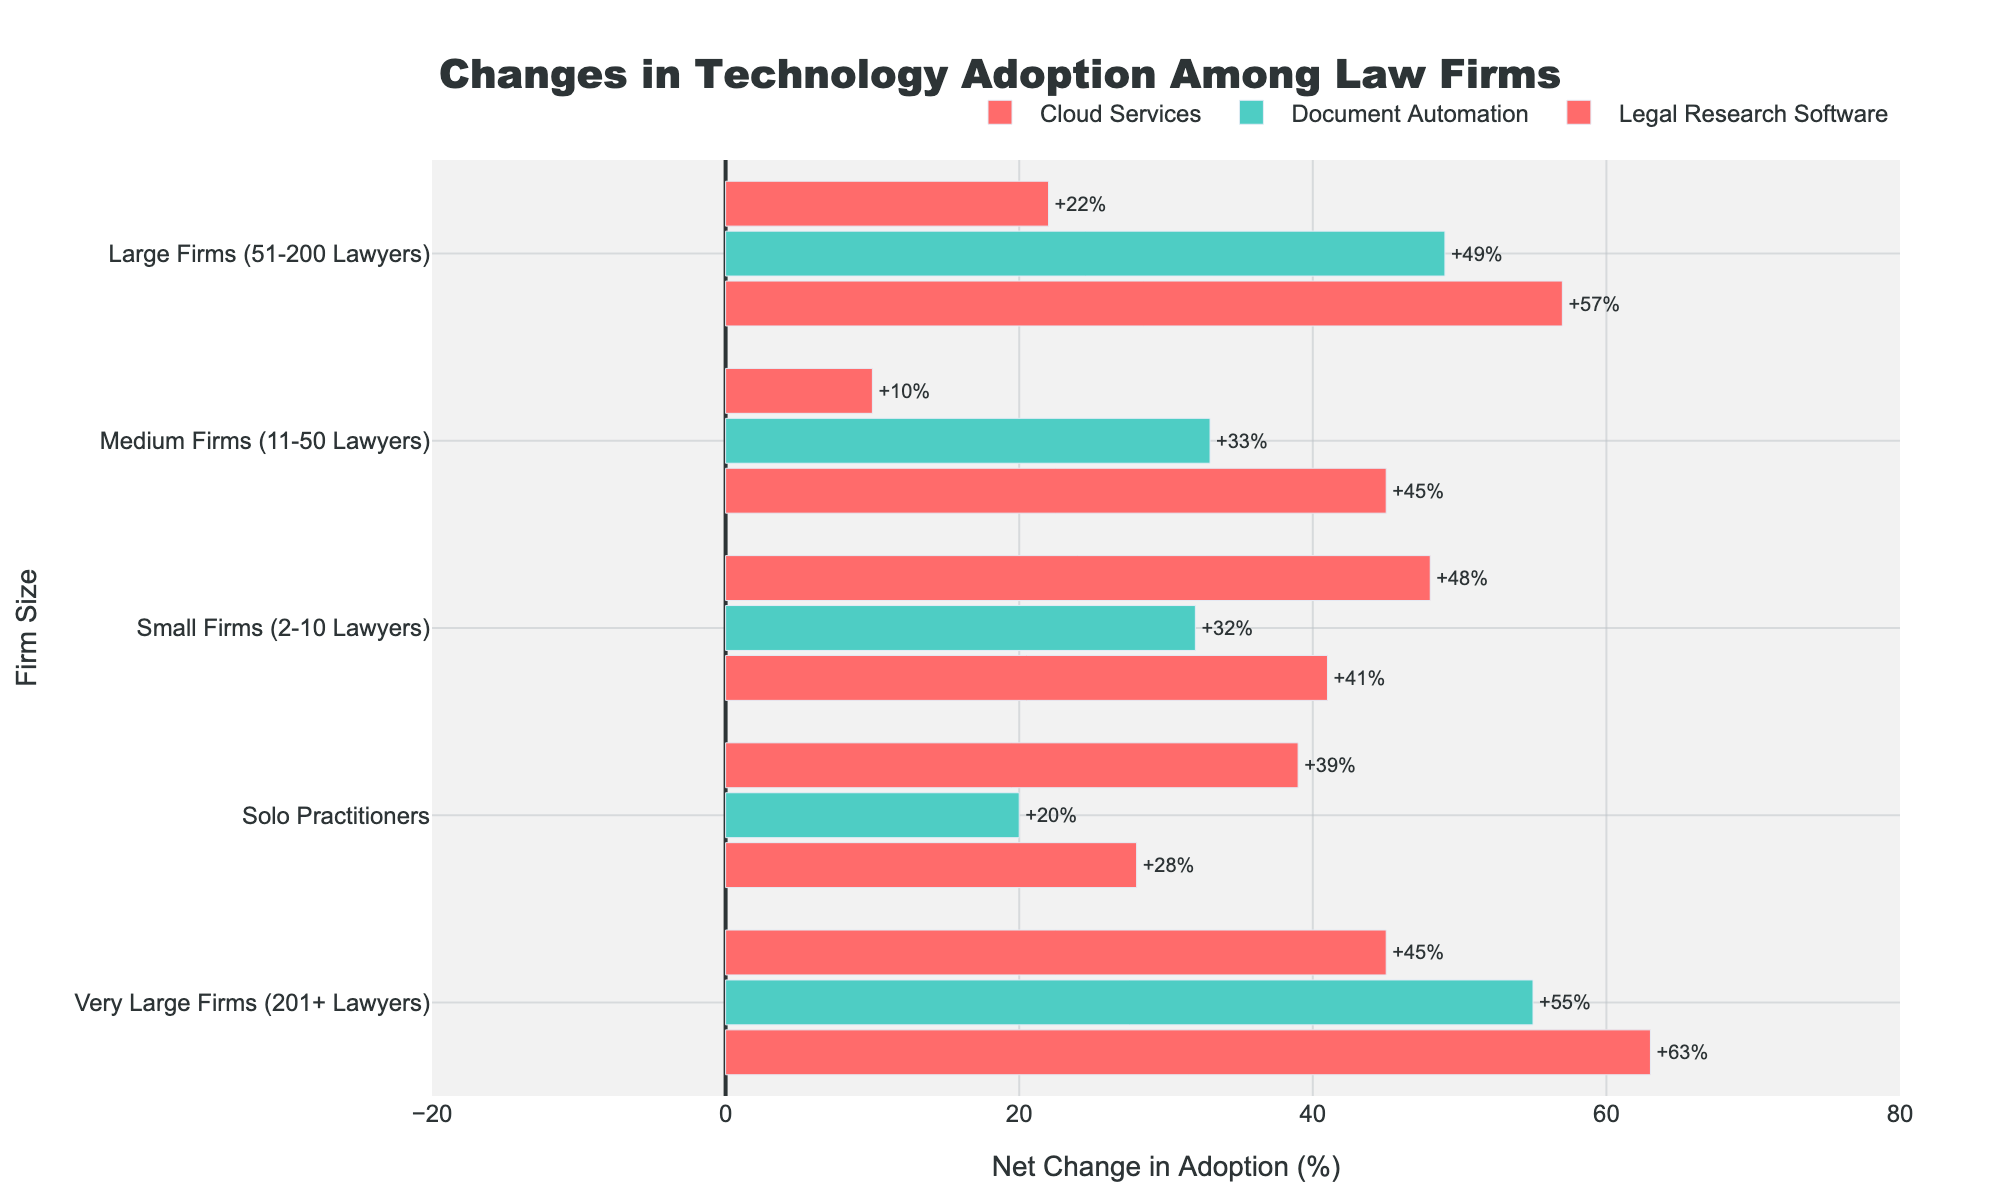What technology category experienced the highest net change in adoption for Very Large Firms (201+ Lawyers)? By comparing the net change values for each technology category within the Very Large Firms (201+ Lawyers) group, we find that Cloud Services has the highest net change.
Answer: Cloud Services Which firm size category has the smallest net increase in adoption for Legal Research Software? Looking at Legal Research Software for each firm size, we find that Medium Firms (11-50 Lawyers) have the smallest net increase at +10%.
Answer: Medium Firms (11-50 Lawyers) What is the net change in adoption for Cloud Services among Small Firms (2-10 Lawyers) and Large Firms (51-200 Lawyers), and which is higher? To answer this, we look at the Cloud Services net change for Small Firms (2-10 Lawyers) which is +41%, and for Large Firms (51-200 Lawyers) which is +57%. Thus, Large Firms have a higher net change in adoption.
Answer: Large Firms (51-200 Lawyers) How much higher is the increase in Document Automation adoption for Very Large Firms (201+ Lawyers) compared to Medium Firms (11-50 Lawyers)? Document Automation adoption increase for Very Large Firms is +65% and for Medium Firms is +33%. The difference is 65% - 33% = 32%.
Answer: 32% Which firm size category has the highest average net change across all technology categories? Calculating the average net change for each firm size:
- Solo Practitioners: (+20% + 28% + 39%) / 3 = 29%
- Small Firms: (+32% + 41% + 48%) / 3 = 40%
- Medium Firms: (+33% + 45% + 10%) / 3 = 29.33%
- Large Firms: (+49% + 57% + 22%) / 3 = 42.67%
- Very Large Firms: (+55% + 63% + 45%) / 3 = 54.33%
 
Thus, Very Large Firms have the highest average net change.
Answer: Very Large Firms (201+ Lawyers) Between Solo Practitioners and Small Firms (2-10 Lawyers), which one has a greater decrease in adoption for Document Automation? The decrease in adoption for Document Automation among Solo Practitioners is 5%, while for Small Firms (2-10 Lawyers) it's 3%. Therefore, Solo Practitioners have a greater decrease.
Answer: Solo Practitioners What is the total net change in adoption for Medium Firms (all technology categories combined)? The net changes for Medium Firms are: Document Automation (+33%), Cloud Services (+45%), and Legal Research Software (+10%). Summing these, the total is 33% + 45% + 10% = 88%.
Answer: 88% Compare the net change in Legal Research Software adoption for Solo Practitioners with that for Very Large Firms (201+ Lawyers). Which is higher and by how much? The net change for Solo Practitioners in Legal Research Software is +39%, while for Very Large Firms it is +45%. The difference is 45% - 39% = 6%.
Answer: Very Large Firms (201+ Lawyers), 6% 